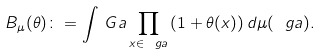Convert formula to latex. <formula><loc_0><loc_0><loc_500><loc_500>B _ { \mu } ( \theta ) \colon = \int _ { \ } G a \prod _ { x \in \ g a } \left ( 1 + \theta ( x ) \right ) d \mu ( \ g a ) .</formula> 